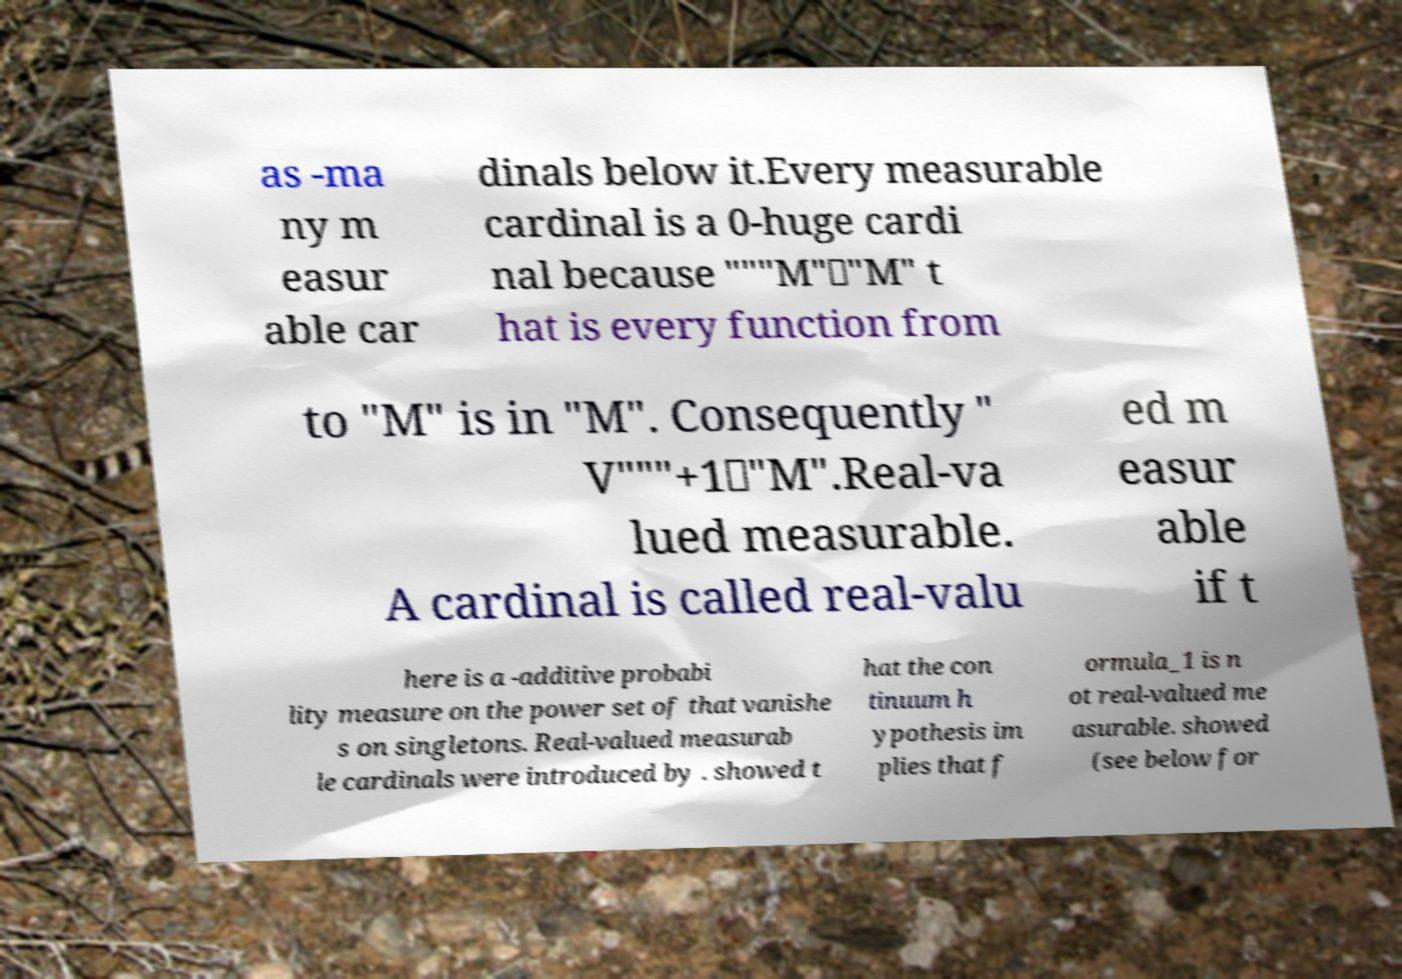Please identify and transcribe the text found in this image. as -ma ny m easur able car dinals below it.Every measurable cardinal is a 0-huge cardi nal because """M"⊆"M" t hat is every function from to "M" is in "M". Consequently " V"""+1⊆"M".Real-va lued measurable. A cardinal is called real-valu ed m easur able if t here is a -additive probabi lity measure on the power set of that vanishe s on singletons. Real-valued measurab le cardinals were introduced by . showed t hat the con tinuum h ypothesis im plies that f ormula_1 is n ot real-valued me asurable. showed (see below for 